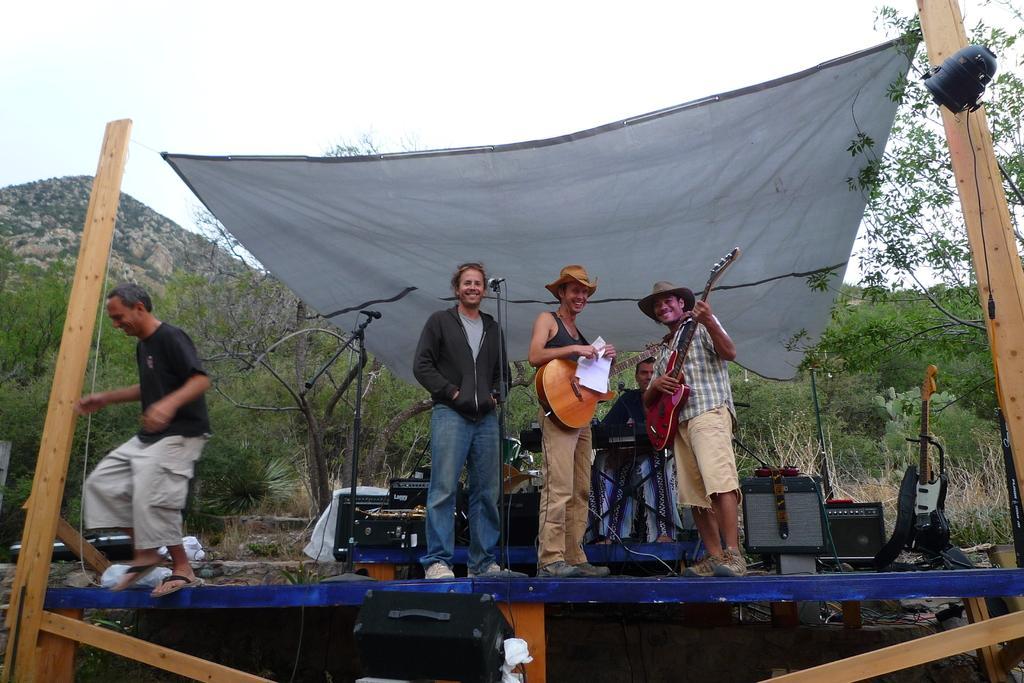Please provide a concise description of this image. In this picture there is a man who is wearing hat, t-shirt, trouser and shoes. He is holding the papers and guitar. Besides him there is another man who is playing a guitar. Behind him there is another man who is wearing jacket, t-shirt, jeans and shoes. In the back I can see the musical instruments. They are standing on the stage. On the left there is a man who is jumping from the stage. In the background I can see many trees, plants, grass and mountains. At the top there is a sky. In the top right corner I can see the focus light. 